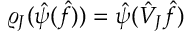<formula> <loc_0><loc_0><loc_500><loc_500>\varrho _ { J } ( \hat { \psi } ( \hat { f } ) ) = \hat { \psi } ( \hat { V } _ { J } \hat { f } )</formula> 